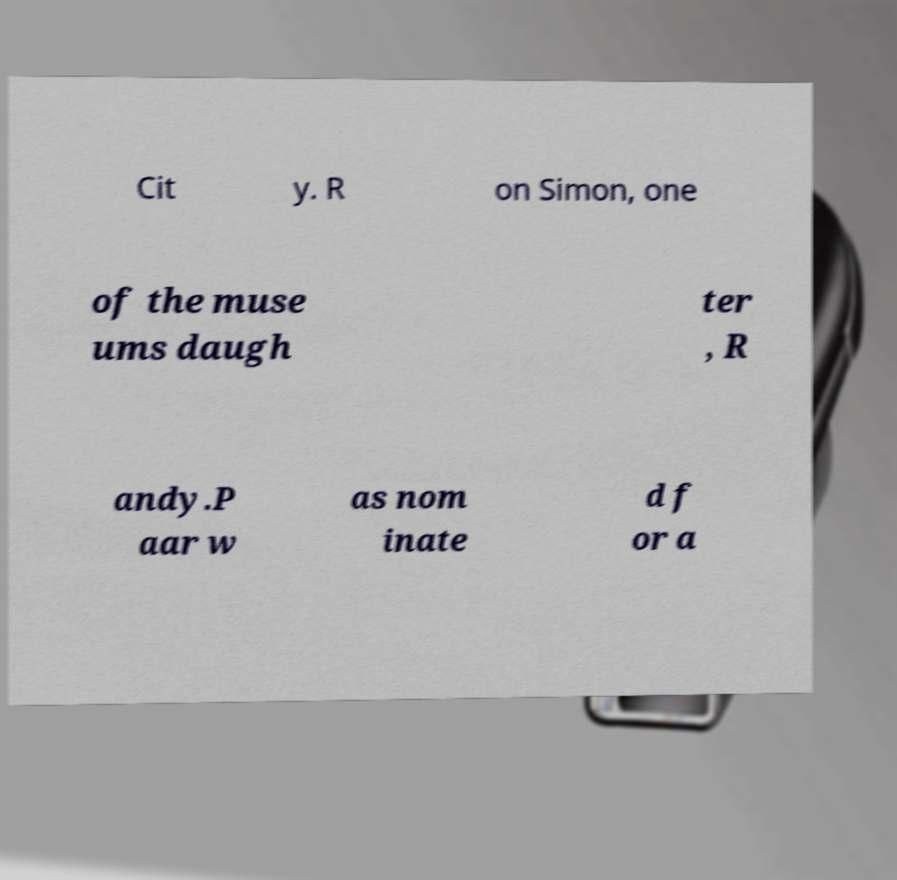There's text embedded in this image that I need extracted. Can you transcribe it verbatim? Cit y. R on Simon, one of the muse ums daugh ter , R andy.P aar w as nom inate d f or a 